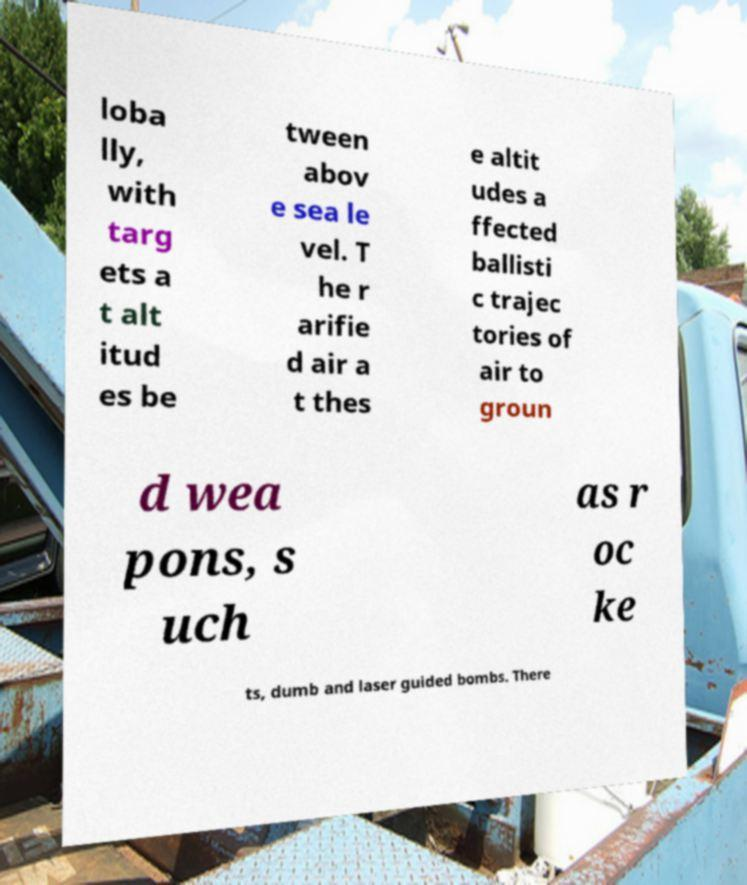Can you accurately transcribe the text from the provided image for me? loba lly, with targ ets a t alt itud es be tween abov e sea le vel. T he r arifie d air a t thes e altit udes a ffected ballisti c trajec tories of air to groun d wea pons, s uch as r oc ke ts, dumb and laser guided bombs. There 